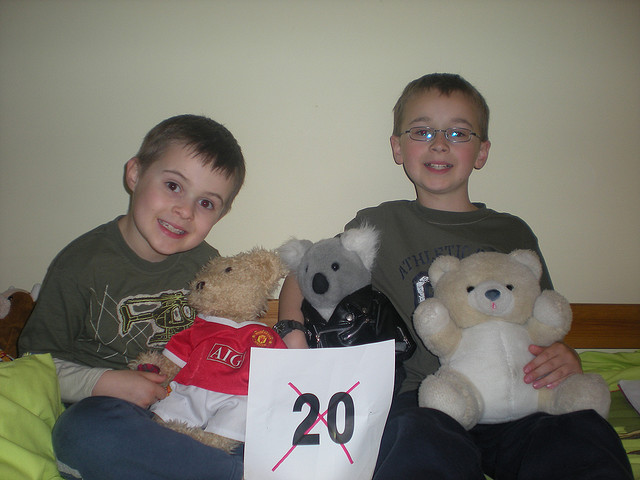What can you say about the kids' expressions? The two children in the image are smiling and appear to be in good spirits, suggesting they are having a fun moment, possibly related to the event hinted at by the displayed number '20'.  Are there any interesting details on the bears' clothing? Yes, one bear is wearing a jersey featuring the logo 'AIG', indicating a sports team association, likely football. It adds a personal touch and may reflect the children's or family's sporting preferences. 